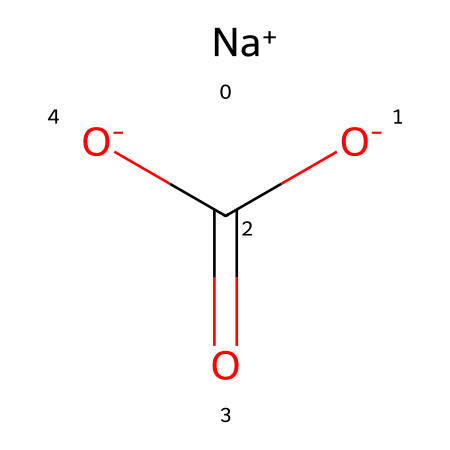What is the common name of this chemical? The chemical structure reveals sodium (Na) and bicarbonate characteristics, commonly known as baking soda.
Answer: baking soda How many hydrogen atoms are present in this chemical? Analyzing the structure, we observe no explicit hydrogen atoms depicted; the bicarbonate ion typically involves an implied presence, but none are shown.
Answer: 0 What ions are present in this chemical? The structure depicts a sodium ion (Na+) and a bicarbonate ion (HCO₃-), confirming the presence of these specific ions.
Answer: sodium and bicarbonate What type of bond connects sodium and bicarbonate in this chemical? The sodium ion interacts with the bicarbonate ion through ionic bonding, characterized by the electrostatic attraction between the oppositely charged ions.
Answer: ionic bond Is this chemical acidic or basic? The bicarbonate ion, HCO₃-, acts as a weak base, indicating that this chemical has basic properties overall.
Answer: basic How many carbon atoms are in the chemical makeup? The structure clearly shows one carbon atom within the bicarbonate component, thus totaling one carbon atom in the overall chemical.
Answer: 1 